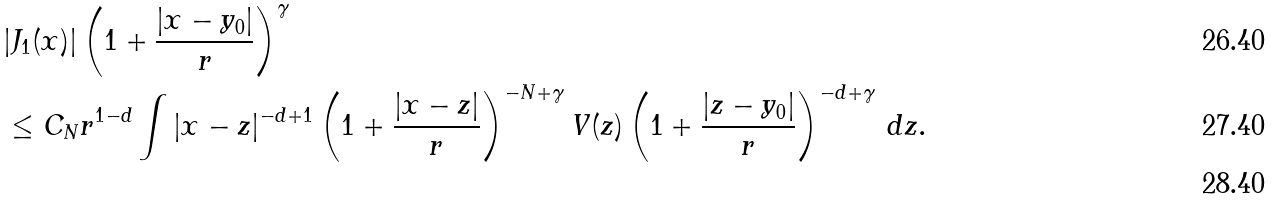Convert formula to latex. <formula><loc_0><loc_0><loc_500><loc_500>& | J _ { 1 } ( x ) | \left ( 1 + \frac { | x - y _ { 0 } | } { r } \right ) ^ { \gamma } \\ & \leq C _ { N } r ^ { 1 - d } \int | x - z | ^ { - d + 1 } \left ( 1 + \frac { | x - z | } { r } \right ) ^ { - N + \gamma } V ( z ) \left ( 1 + \frac { | z - y _ { 0 } | } { r } \right ) ^ { - d + \gamma } \, d z . \\</formula> 